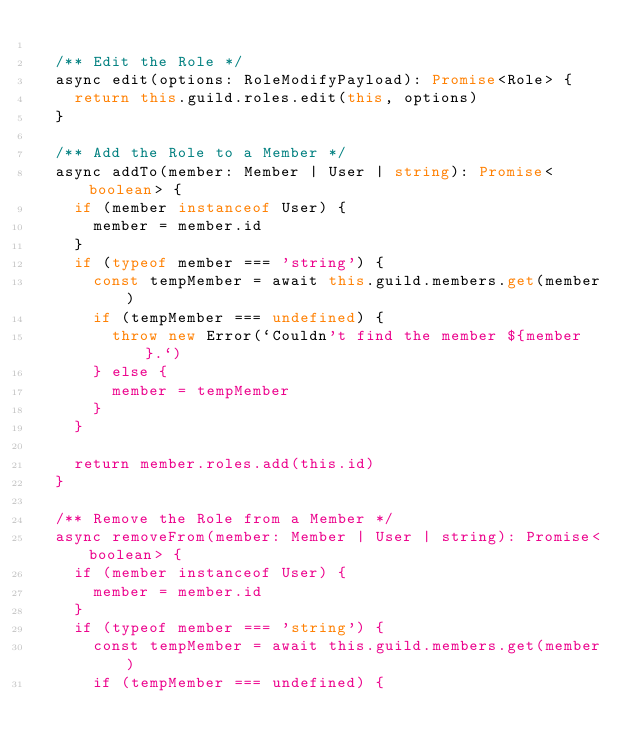Convert code to text. <code><loc_0><loc_0><loc_500><loc_500><_TypeScript_>
  /** Edit the Role */
  async edit(options: RoleModifyPayload): Promise<Role> {
    return this.guild.roles.edit(this, options)
  }

  /** Add the Role to a Member */
  async addTo(member: Member | User | string): Promise<boolean> {
    if (member instanceof User) {
      member = member.id
    }
    if (typeof member === 'string') {
      const tempMember = await this.guild.members.get(member)
      if (tempMember === undefined) {
        throw new Error(`Couldn't find the member ${member}.`)
      } else {
        member = tempMember
      }
    }

    return member.roles.add(this.id)
  }

  /** Remove the Role from a Member */
  async removeFrom(member: Member | User | string): Promise<boolean> {
    if (member instanceof User) {
      member = member.id
    }
    if (typeof member === 'string') {
      const tempMember = await this.guild.members.get(member)
      if (tempMember === undefined) {</code> 